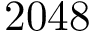<formula> <loc_0><loc_0><loc_500><loc_500>2 0 4 8</formula> 